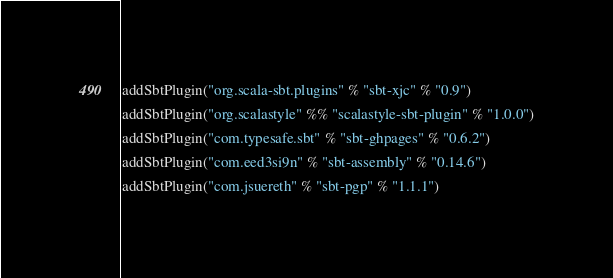<code> <loc_0><loc_0><loc_500><loc_500><_Scala_>addSbtPlugin("org.scala-sbt.plugins" % "sbt-xjc" % "0.9")
addSbtPlugin("org.scalastyle" %% "scalastyle-sbt-plugin" % "1.0.0")
addSbtPlugin("com.typesafe.sbt" % "sbt-ghpages" % "0.6.2")
addSbtPlugin("com.eed3si9n" % "sbt-assembly" % "0.14.6")
addSbtPlugin("com.jsuereth" % "sbt-pgp" % "1.1.1")

</code> 